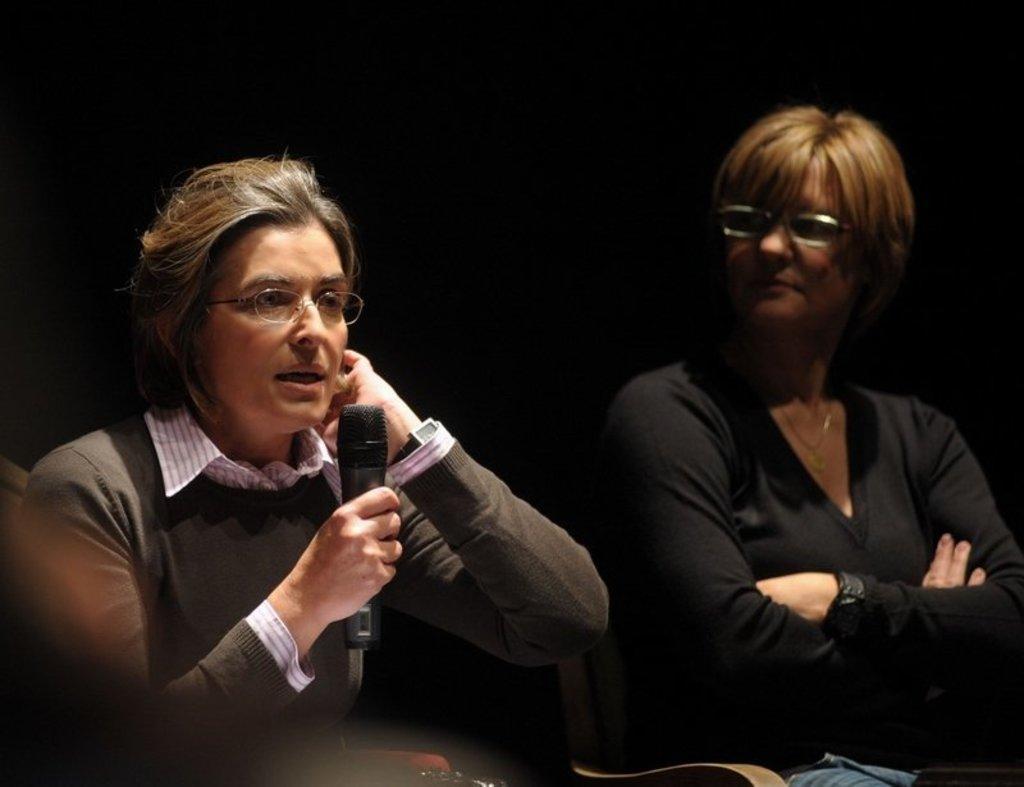In one or two sentences, can you explain what this image depicts? There are two women's sitting on the chair in this image. The left side woman is wearing brown color t shirt and holding a mic in her hands and speaking. She is wearing spectacles on her face. The woman on the right side is wearing black t shirt and also she is wearing spectacles on her face. 